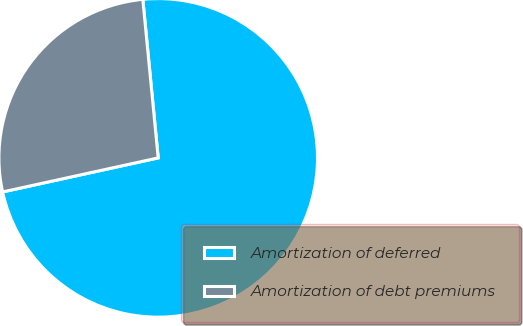<chart> <loc_0><loc_0><loc_500><loc_500><pie_chart><fcel>Amortization of deferred<fcel>Amortization of debt premiums<nl><fcel>73.11%<fcel>26.89%<nl></chart> 